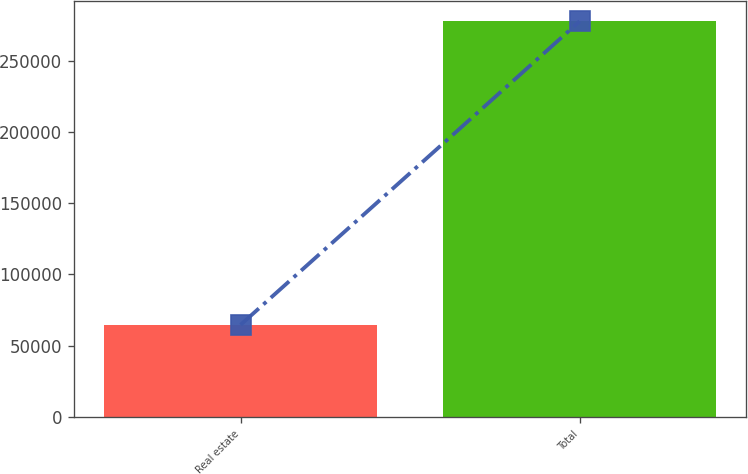Convert chart. <chart><loc_0><loc_0><loc_500><loc_500><bar_chart><fcel>Real estate<fcel>Total<nl><fcel>64597<fcel>277638<nl></chart> 